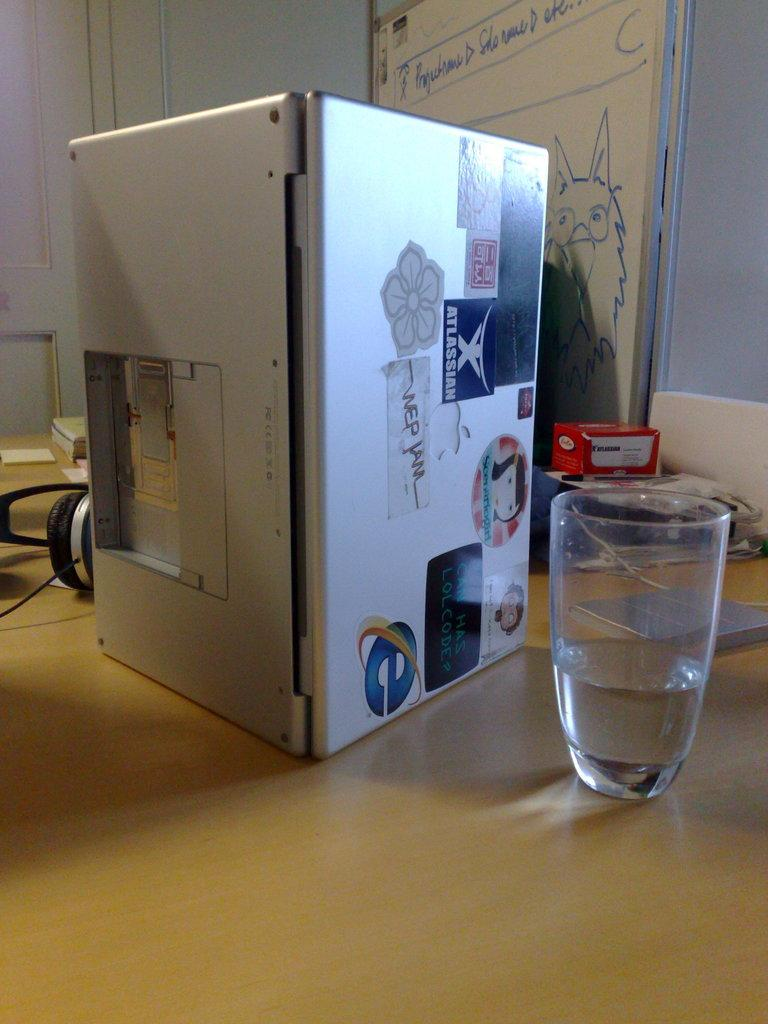Provide a one-sentence caption for the provided image. A Macbook is laying open on its side with an Atlassian sticker and other stickers on it. 